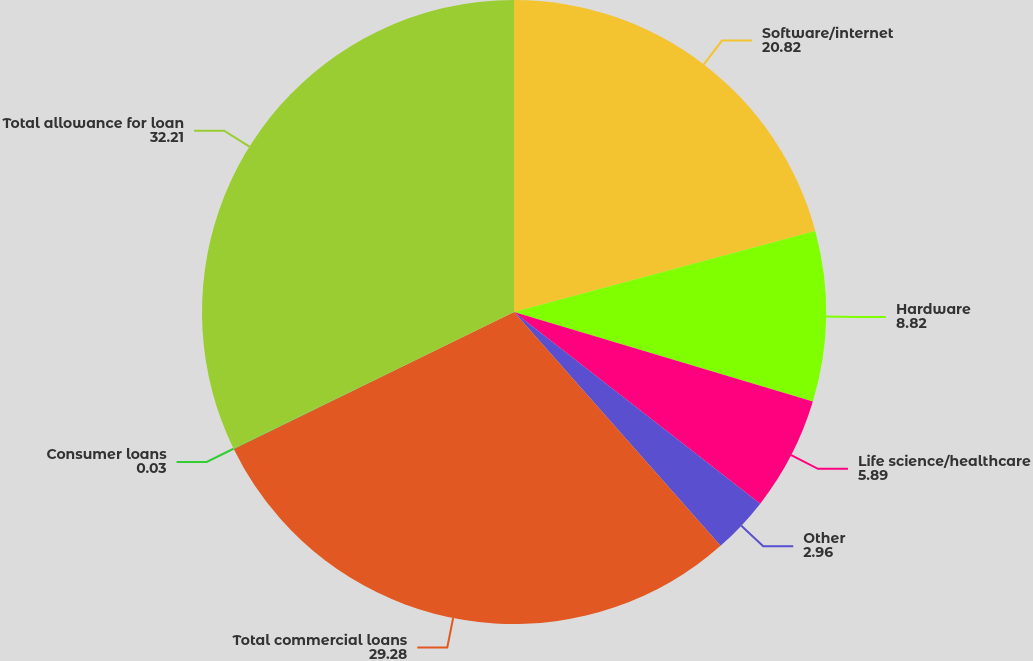Convert chart to OTSL. <chart><loc_0><loc_0><loc_500><loc_500><pie_chart><fcel>Software/internet<fcel>Hardware<fcel>Life science/healthcare<fcel>Other<fcel>Total commercial loans<fcel>Consumer loans<fcel>Total allowance for loan<nl><fcel>20.82%<fcel>8.82%<fcel>5.89%<fcel>2.96%<fcel>29.28%<fcel>0.03%<fcel>32.21%<nl></chart> 